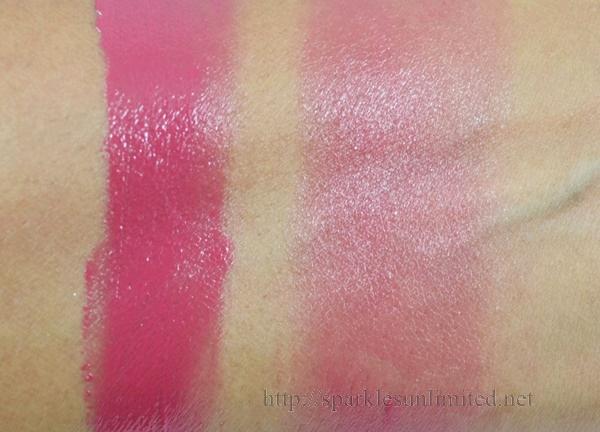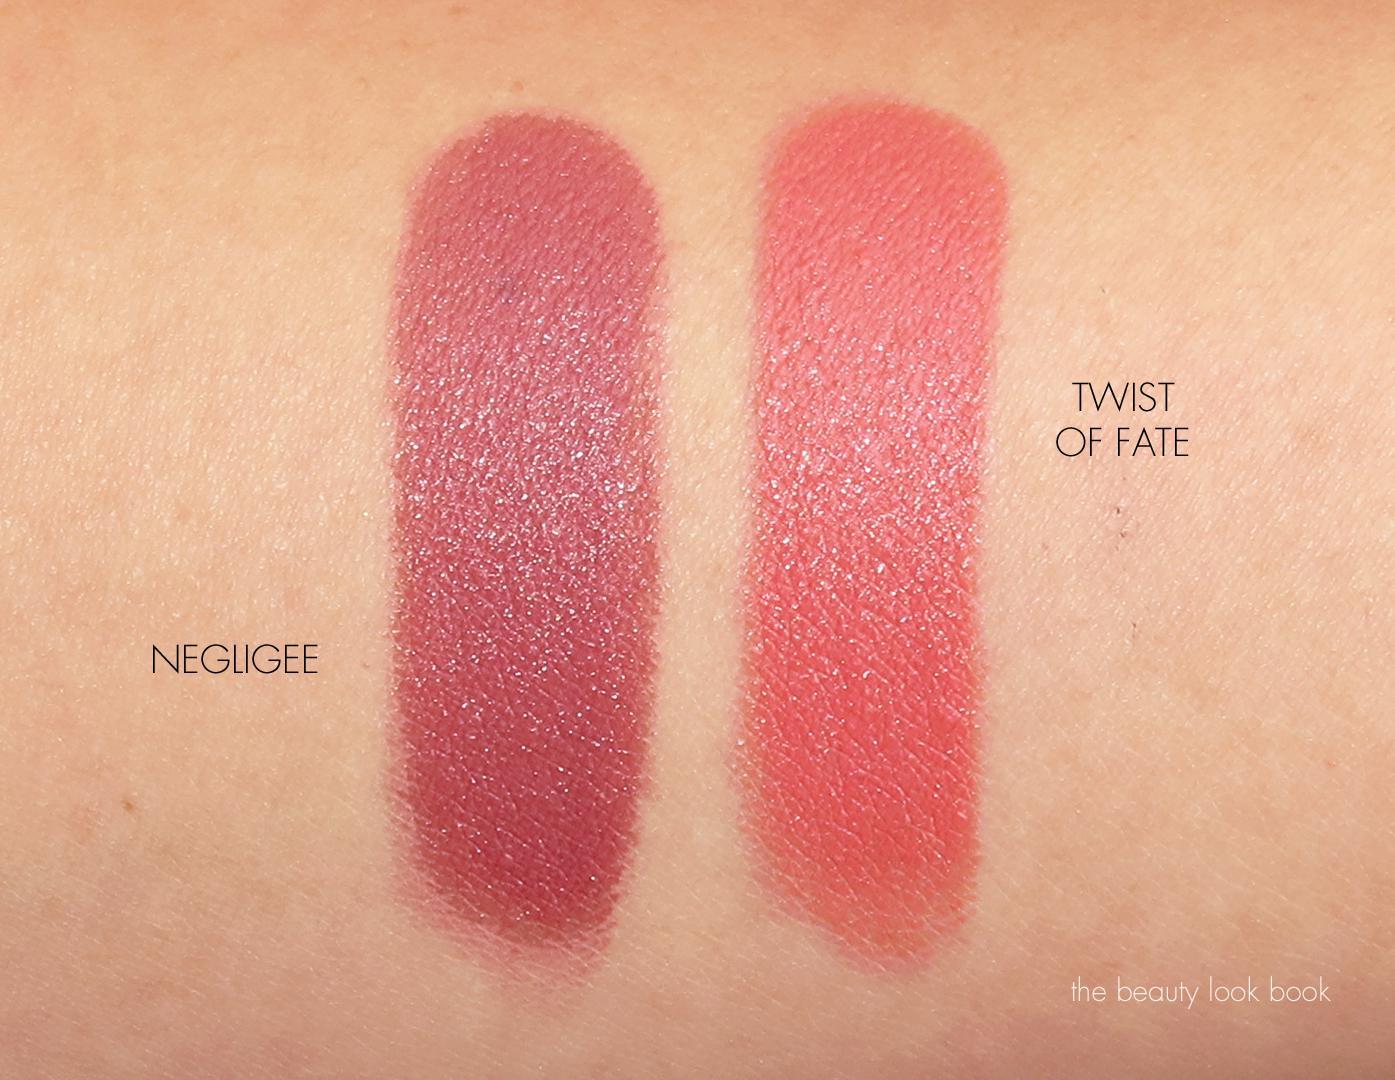The first image is the image on the left, the second image is the image on the right. Analyze the images presented: Is the assertion "There are five shades of lipstick on a person's arm." valid? Answer yes or no. No. 